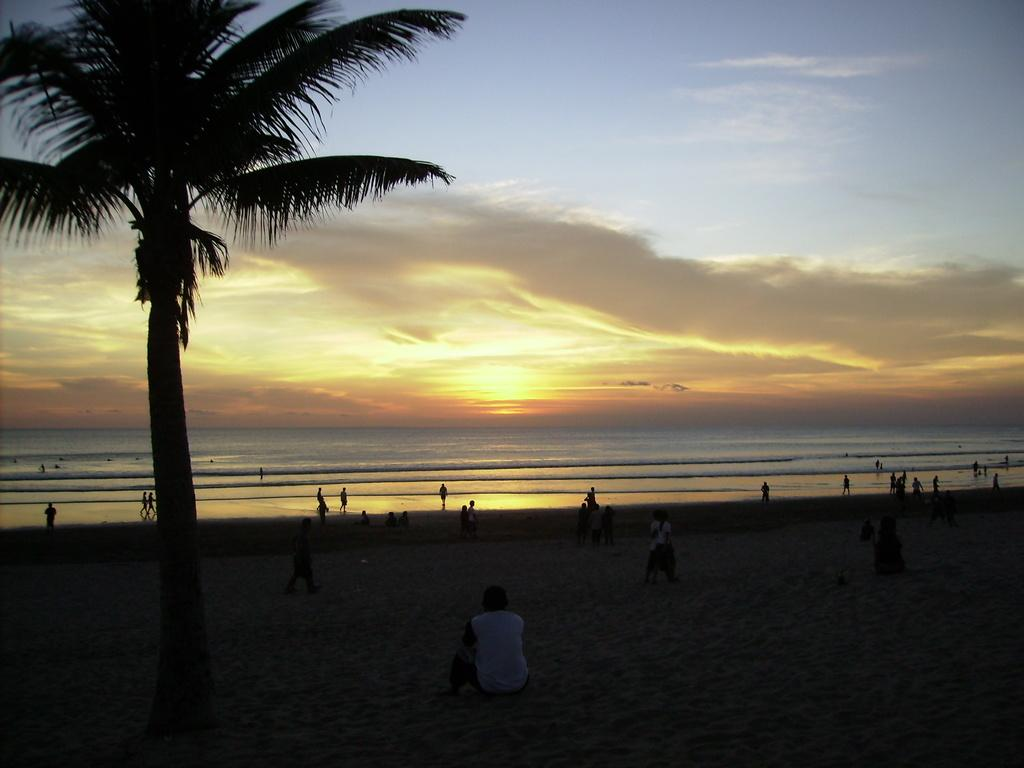What is the main subject of the image? The main subject of the image is a group of people. Where are the people located in the image? The people are on the sand in the image. What can be seen to the left of the image? There is a tree to the left of the image. What is visible in the background of the image? There is water and clouds visible in the background of the image. What part of the sky is visible in the image? The sky is visible in the background of the image. What type of wax can be seen melting on the people's skin in the image? There is no wax present in the image, and therefore no such activity can be observed. 